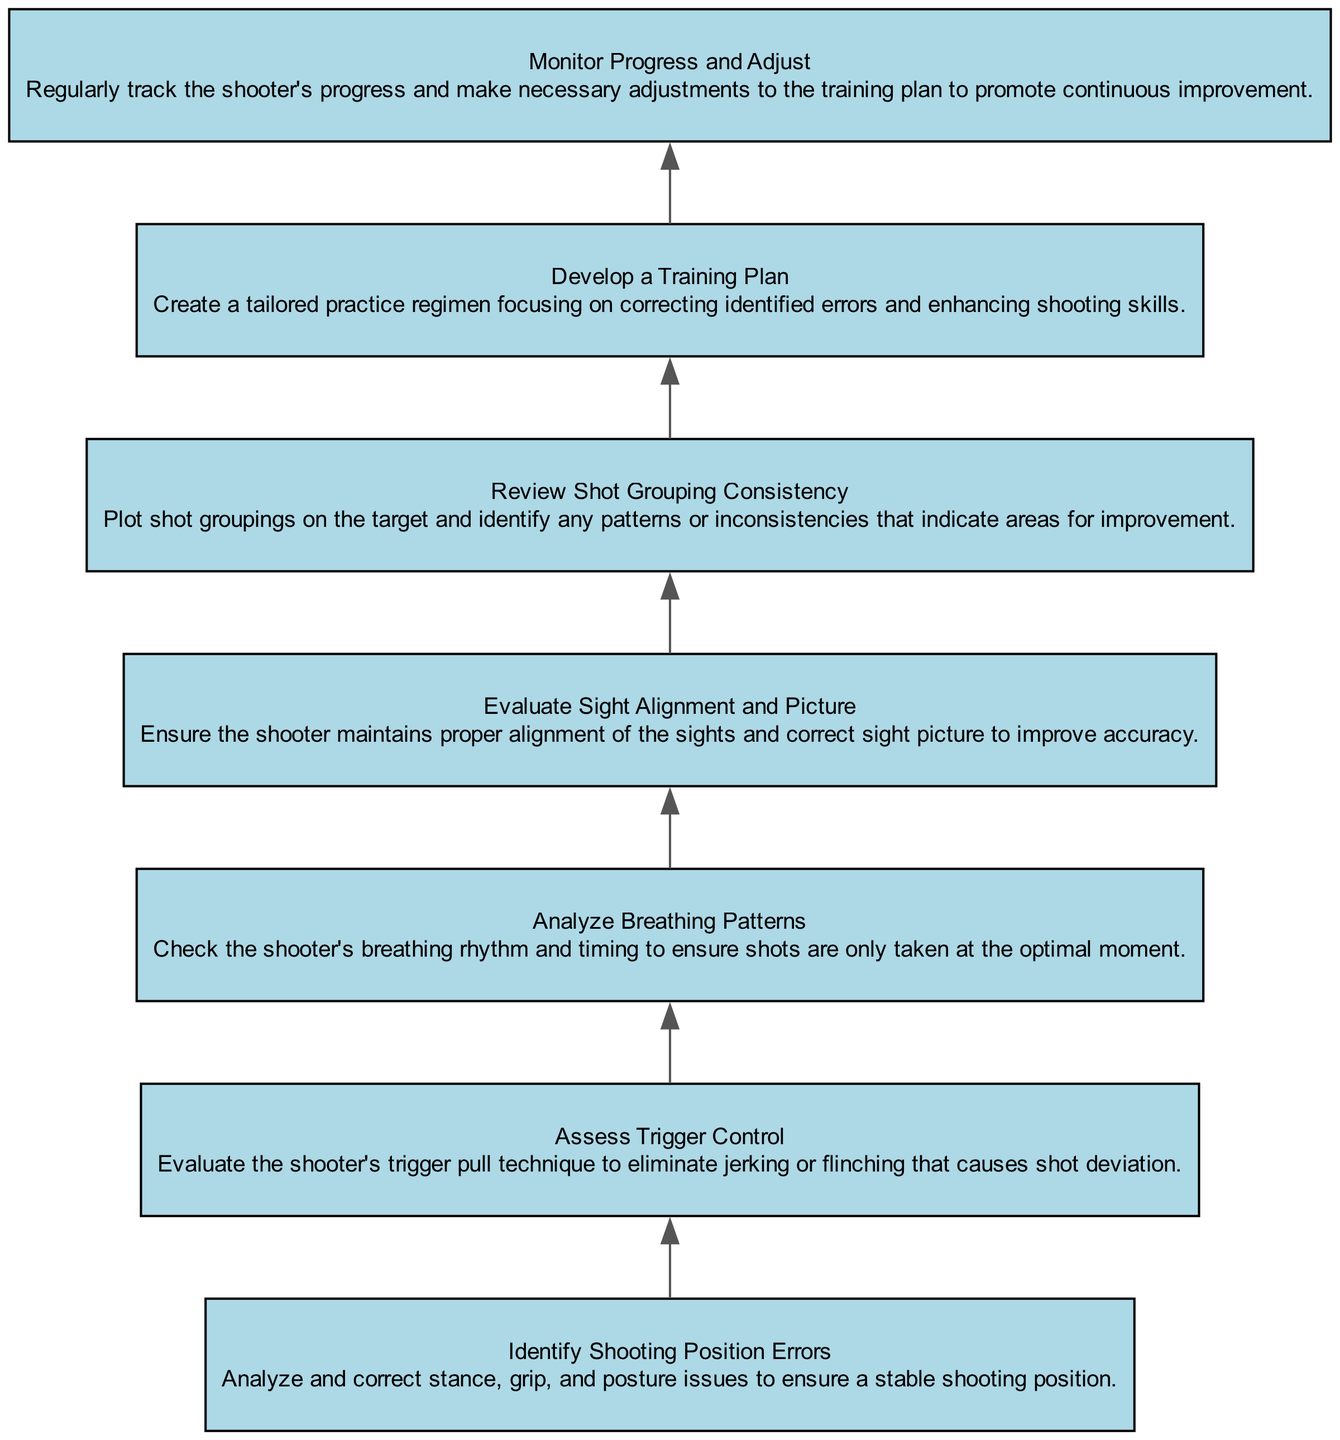What is the top node in the diagram? The top node in the diagram is determined by the flow moving from the bottom to the top. The last element in the sequence is "Monitor Progress and Adjust," making it the top node.
Answer: Monitor Progress and Adjust How many total nodes are present in the diagram? By counting each of the distinct elements listed in the data, we can see there are seven nodes representing various techniques.
Answer: 7 What is the second node in the flow? The nodes are ordered from bottom to top. After "Develop a Training Plan," the next node is "Evaluate Sight Alignment and Picture," which is the second node in the sequence.
Answer: Evaluate Sight Alignment and Picture Which node addresses grip issues? The node that specifically mentions grip issues is "Identify Shooting Position Errors," where it highlights correcting stance, grip, and posture issues for a stable shooting position.
Answer: Identify Shooting Position Errors What is the relationship between "Assess Trigger Control" and "Analyze Breathing Patterns"? In the flowchart, "Assess Trigger Control" is a node that leads directly to "Analyze Breathing Patterns," indicating that assessing trigger control is a prerequisite to analyzing breathing patterns in the shooting process.
Answer: Directly connected What is the last step before developing a training plan? To find the last step before "Develop a Training Plan," we examine the flow and see that "Review Shot Grouping Consistency" is the immediate predecessor, highlighting a reflection on shot performance before planning training.
Answer: Review Shot Grouping Consistency Describe the sequence of nodes leading to "Monitor Progress and Adjust." The sequence includes three nodes: first "Develop a Training Plan," followed by "Monitor Progress and Adjust," illustrating a structured approach to continual improvement in shooting by revising the training based on progress tracking.
Answer: Develop a Training Plan → Monitor Progress and Adjust Which node focuses on evaluating consistency in shooting? The node directly focused on evaluating consistency in shooting patterns is "Review Shot Grouping Consistency," which emphasizes the importance of assessing shot groupings to identify areas that need improvement.
Answer: Review Shot Grouping Consistency 